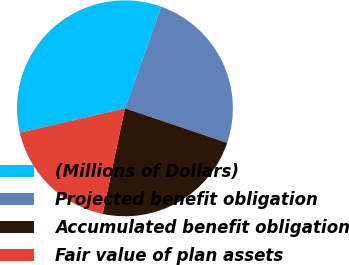Convert chart to OTSL. <chart><loc_0><loc_0><loc_500><loc_500><pie_chart><fcel>(Millions of Dollars)<fcel>Projected benefit obligation<fcel>Accumulated benefit obligation<fcel>Fair value of plan assets<nl><fcel>34.08%<fcel>24.73%<fcel>23.13%<fcel>18.06%<nl></chart> 